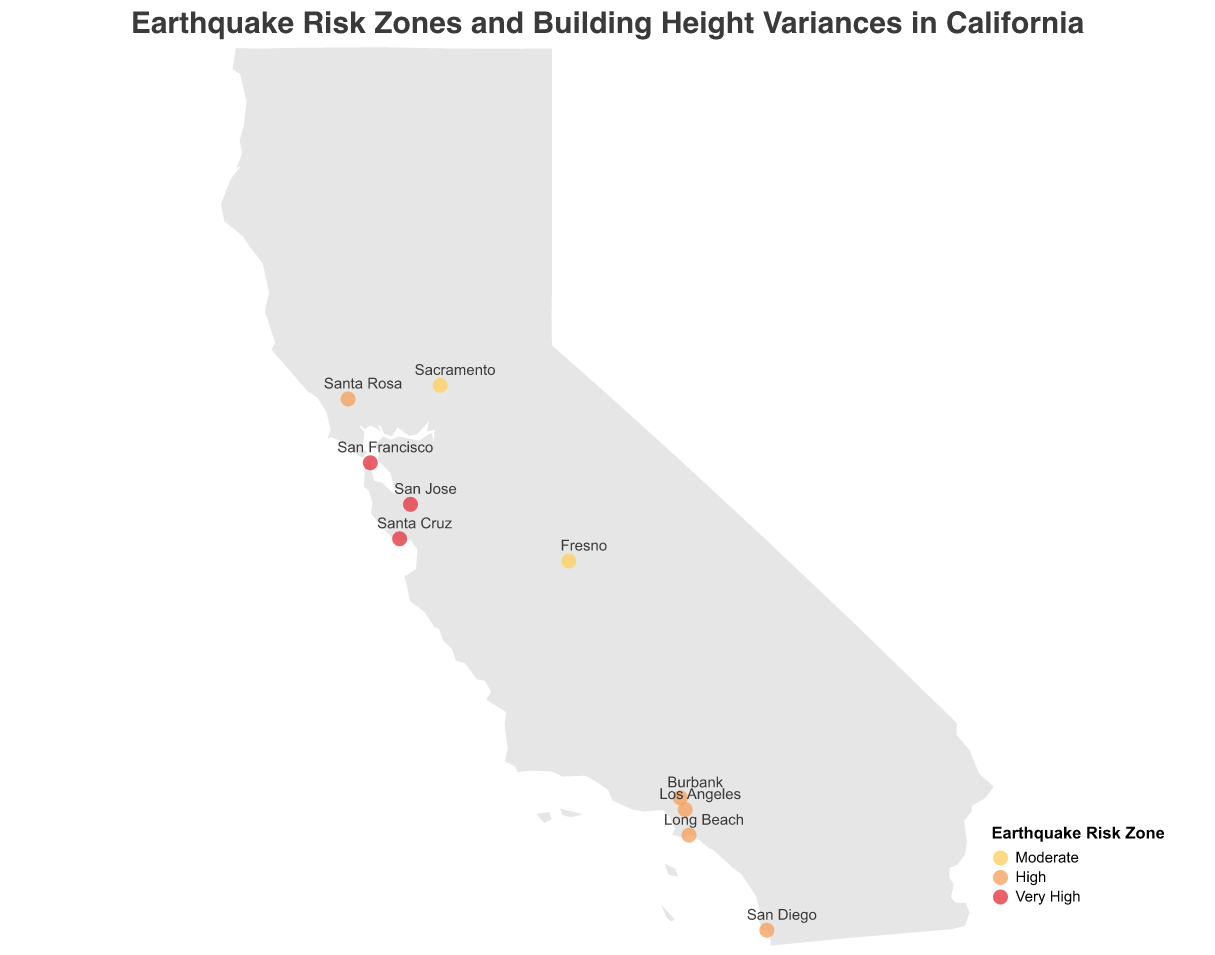How many cities are displayed on the plot? Count the number of labeled city points on the plot. There are 10 cities annotated on the map with labels.
Answer: 10 Which city falls in the "Very High" earthquake risk zone and has the tallest maximum building height limit? Identify cities with the "Very High" earthquake risk zone and compare their maximum building height limits. San Francisco has the tallest maximum building height limit in the "Very High" earthquake risk zone, which is 240 feet.
Answer: San Francisco What additional requirement is imposed on buildings in San Jose? Check the tooltip information for San Jose. San Jose requires "Tuned mass dampers mandatory."
Answer: Tuned mass dampers mandatory Which city has a variance requested height that is 100 feet taller than its maximum building height? Look at the difference between the "VarianceRequestedHeight" and "MaxBuildingHeight" for each city. Sacramento has a difference of 100 feet between its variance requested height (500 feet) and maximum building height (400 feet).
Answer: Sacramento What is the predominant earthquake risk zone color for cities in the plot? Review the colors encoding the earthquake risk zones and determine the most frequent. The predominant earthquake risk zone color is orange, which represents “High” risk.
Answer: “High” What is the main title of the plot? The main title text is located at the top center of the plot. The title is "Earthquake Risk Zones and Building Height Variances in California."
Answer: Earthquake Risk Zones and Building Height Variances in California Which city has the smallest requested variance in building height? Look at the variance requested heights for each city and identify the smallest value. Santa Rosa has the smallest requested variance in building height, which is 50 feet.
Answer: Santa Rosa How many cities fall into the "Moderate" earthquake risk zone? Count the cities categorized as "Moderate" in the earthquake risk zone. There are two cities: Sacramento and Fresno.
Answer: 2 Compare the additional building requirements for San Francisco and San Diego. What are they? Check the tooltip information for both cities and compare the additional requirements listed. San Francisco requires "Seismic isolators," while San Diego requires "Advanced damping systems."
Answer: Seismic isolators vs. Advanced damping systems 